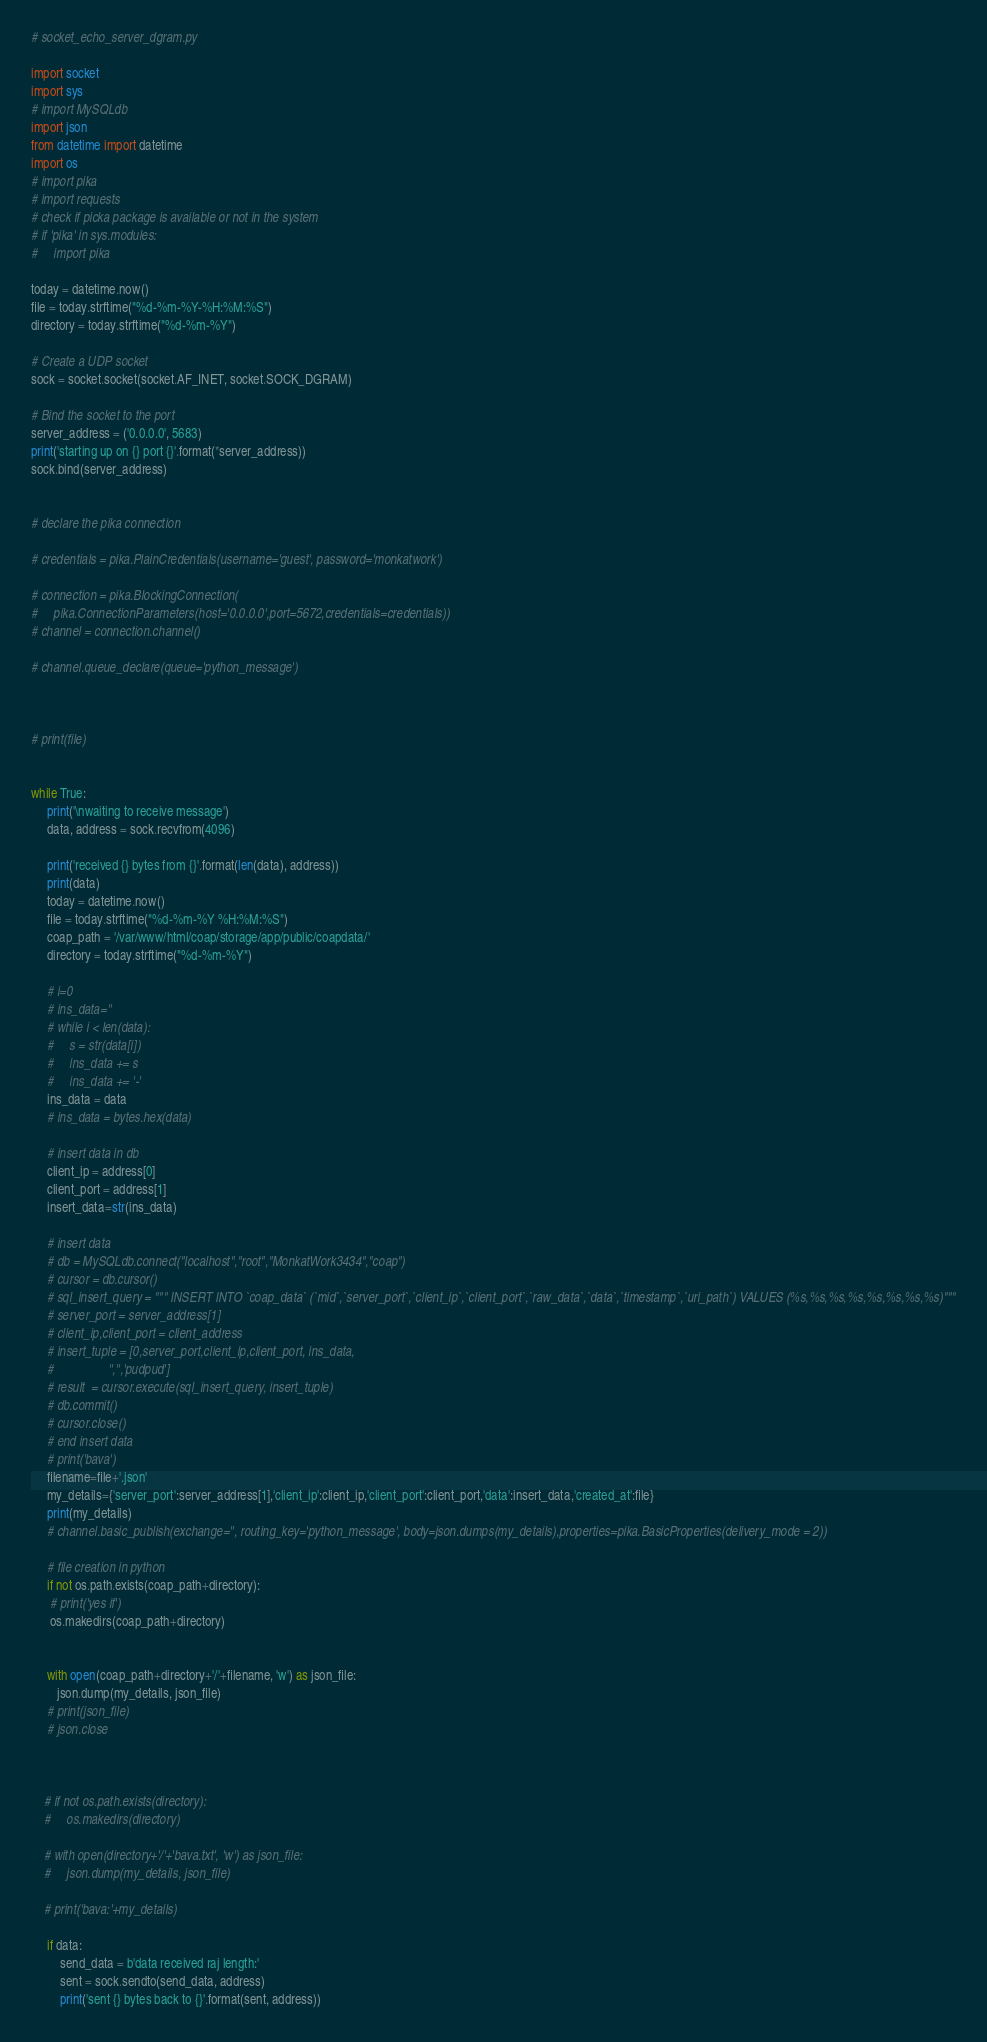Convert code to text. <code><loc_0><loc_0><loc_500><loc_500><_Python_>
# socket_echo_server_dgram.py

import socket
import sys
# import MySQLdb
import json
from datetime import datetime
import os
# import pika
# import requests
# check if picka package is available or not in the system
# if 'pika' in sys.modules:
#     import pika

today = datetime.now()
file = today.strftime("%d-%m-%Y-%H:%M:%S")
directory = today.strftime("%d-%m-%Y")

# Create a UDP socket
sock = socket.socket(socket.AF_INET, socket.SOCK_DGRAM)

# Bind the socket to the port
server_address = ('0.0.0.0', 5683)
print('starting up on {} port {}'.format(*server_address))
sock.bind(server_address)


# declare the pika connection

# credentials = pika.PlainCredentials(username='guest', password='monkatwork')

# connection = pika.BlockingConnection(
#     pika.ConnectionParameters(host='0.0.0.0',port=5672,credentials=credentials))
# channel = connection.channel()

# channel.queue_declare(queue='python_message')



# print(file)


while True:
     print('\nwaiting to receive message')
     data, address = sock.recvfrom(4096)
    
     print('received {} bytes from {}'.format(len(data), address))
     print(data)
     today = datetime.now()
     file = today.strftime("%d-%m-%Y %H:%M:%S")
     coap_path = '/var/www/html/coap/storage/app/public/coapdata/'
     directory = today.strftime("%d-%m-%Y")
     
     # i=0
     # ins_data=''
     # while i < len(data):
     #     s = str(data[i]) 
     #     ins_data += s 
     #     ins_data += '-' 
     ins_data = data
     # ins_data = bytes.hex(data)

     # insert data in db
     client_ip = address[0]
     client_port = address[1]
     insert_data=str(ins_data)
     
     # insert data
     # db = MySQLdb.connect("localhost","root","MonkatWork3434","coap")
     # cursor = db.cursor()
     # sql_insert_query = """ INSERT INTO `coap_data` (`mid`,`server_port`,`client_ip`,`client_port`,`raw_data`,`data`,`timestamp`,`uri_path`) VALUES (%s,%s,%s,%s,%s,%s,%s,%s)"""
     # server_port = server_address[1]
     # client_ip,client_port = client_address
     # insert_tuple = [0,server_port,client_ip,client_port, ins_data,
     #                 '','','pudpud']
     # result  = cursor.execute(sql_insert_query, insert_tuple)
     # db.commit()
     # cursor.close()
     # end insert data
     # print('bava')
     filename=file+'.json'
     my_details={'server_port':server_address[1],'client_ip':client_ip,'client_port':client_port,'data':insert_data,'created_at':file}
     print(my_details)
     # channel.basic_publish(exchange='', routing_key='python_message', body=json.dumps(my_details),properties=pika.BasicProperties(delivery_mode = 2))

     # file creation in python 
     if not os.path.exists(coap_path+directory):
      # print('yes if')
      os.makedirs(coap_path+directory)


     with open(coap_path+directory+'/'+filename, 'w') as json_file:
     	json.dump(my_details, json_file)
     # print(json_file)
     # json.close


    
    # if not os.path.exists(directory):
    #     os.makedirs(directory)

    # with open(directory+'/'+'bava.txt', 'w') as json_file:  
    #     json.dump(my_details, json_file)

    # print('bava:'+my_details)
     
     if data:
         send_data = b'data received raj length:'
         sent = sock.sendto(send_data, address)
         print('sent {} bytes back to {}'.format(sent, address))
</code> 